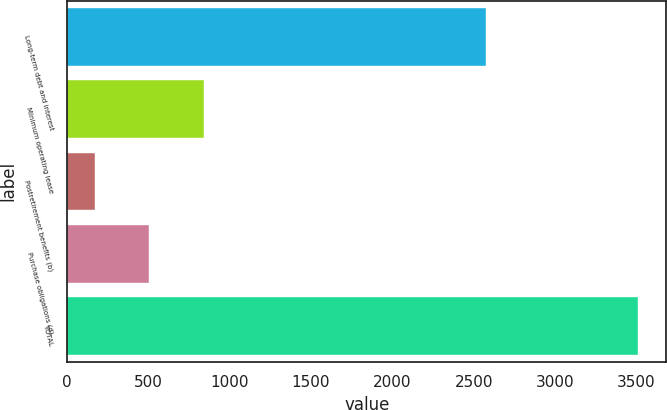Convert chart. <chart><loc_0><loc_0><loc_500><loc_500><bar_chart><fcel>Long-term debt and interest<fcel>Minimum operating lease<fcel>Postretirement benefits (b)<fcel>Purchase obligations (d)<fcel>TOTAL<nl><fcel>2575<fcel>840.1<fcel>172.5<fcel>506.3<fcel>3510.5<nl></chart> 